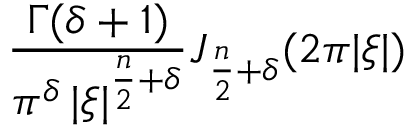Convert formula to latex. <formula><loc_0><loc_0><loc_500><loc_500>{ \frac { \Gamma ( \delta + 1 ) } { \pi ^ { \delta } \, | { \xi } | ^ { { \frac { n } { 2 } } + \delta } } } J _ { { \frac { n } { 2 } } + \delta } ( 2 \pi | { \xi } | )</formula> 